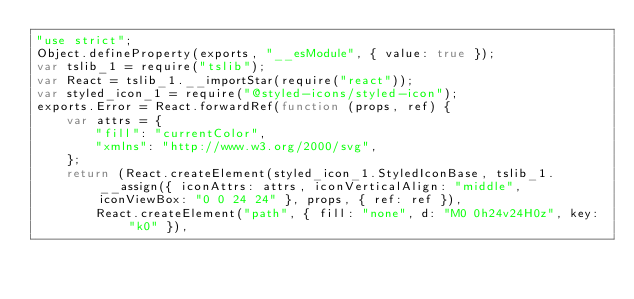<code> <loc_0><loc_0><loc_500><loc_500><_JavaScript_>"use strict";
Object.defineProperty(exports, "__esModule", { value: true });
var tslib_1 = require("tslib");
var React = tslib_1.__importStar(require("react"));
var styled_icon_1 = require("@styled-icons/styled-icon");
exports.Error = React.forwardRef(function (props, ref) {
    var attrs = {
        "fill": "currentColor",
        "xmlns": "http://www.w3.org/2000/svg",
    };
    return (React.createElement(styled_icon_1.StyledIconBase, tslib_1.__assign({ iconAttrs: attrs, iconVerticalAlign: "middle", iconViewBox: "0 0 24 24" }, props, { ref: ref }),
        React.createElement("path", { fill: "none", d: "M0 0h24v24H0z", key: "k0" }),</code> 